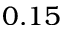Convert formula to latex. <formula><loc_0><loc_0><loc_500><loc_500>0 . 1 5</formula> 